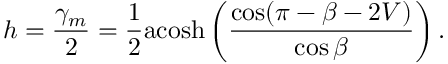Convert formula to latex. <formula><loc_0><loc_0><loc_500><loc_500>h = \frac { \gamma _ { m } } { 2 } = \frac { 1 } { 2 } a \cosh \left ( \frac { \cos ( \pi - \beta - 2 V ) } { \cos \beta } \right ) .</formula> 